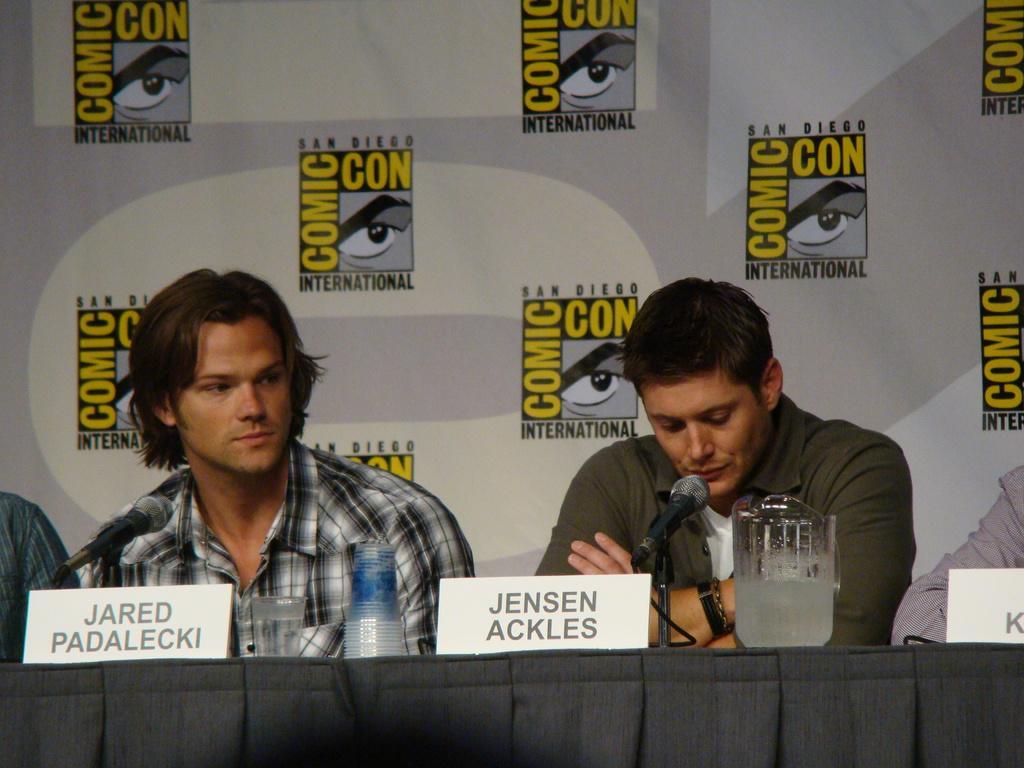Can you describe this image briefly? In this image I can see few people are sitting. I can see few mic, glasses, boards and few objects on the table. Background I can see the cream and white color surface and something is written on it. 